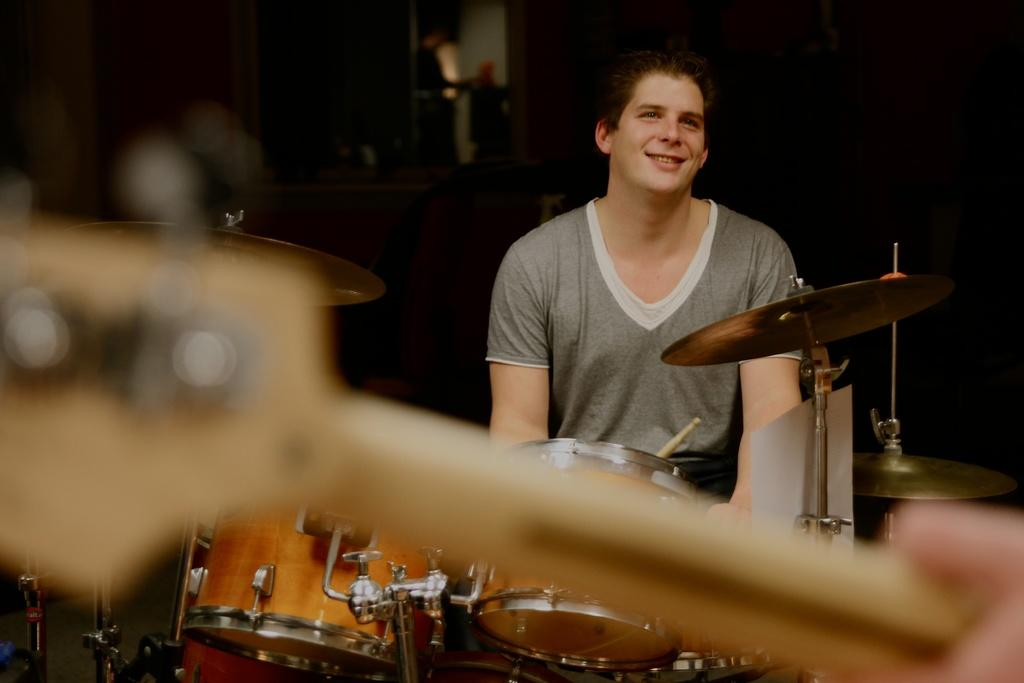Who is the main subject in the image? There is a man in the image. What is the man doing in the image? The man is playing drums in the image. How does the man appear to feel in the image? The man is smiling in the image. What can be seen in the background of the image? The background of the man is blurred in the image. What type of pizzas can be seen in the image? There are no pizzas present in the image. Where is the drawer located in the image? There is no drawer present in the image. 